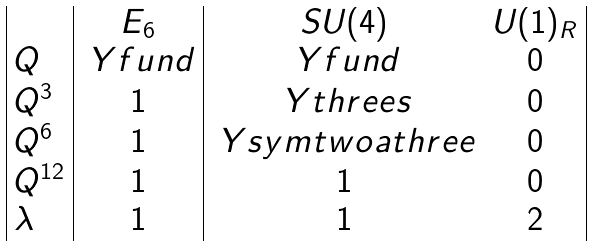<formula> <loc_0><loc_0><loc_500><loc_500>\begin{array} { | l | c | c c | } & E _ { 6 } & S U ( 4 ) & U ( 1 ) _ { R } \\ Q & \ Y f u n d & \ Y f u n d & 0 \\ Q ^ { 3 } & 1 & \ Y t h r e e s & 0 \\ Q ^ { 6 } & 1 & \ Y s y m t w o a t h r e e & 0 \\ Q ^ { 1 2 } & 1 & 1 & 0 \\ \lambda & 1 & 1 & 2 \\ \end{array}</formula> 